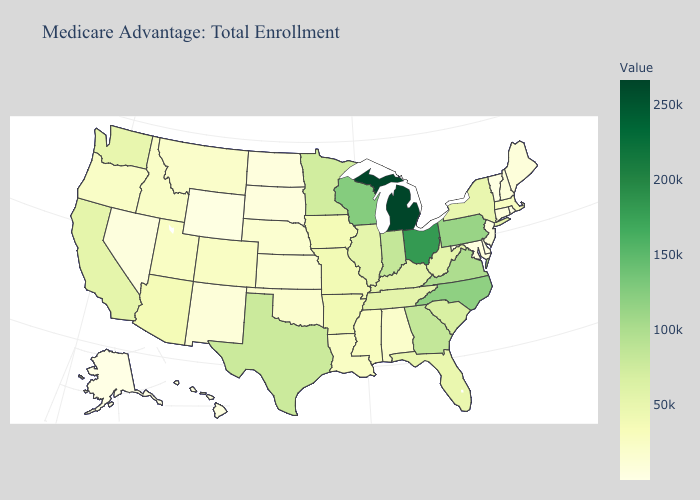Among the states that border North Dakota , does Minnesota have the lowest value?
Give a very brief answer. No. Among the states that border Illinois , does Wisconsin have the highest value?
Short answer required. Yes. Among the states that border Vermont , which have the highest value?
Quick response, please. New York. Does Arizona have a lower value than Minnesota?
Give a very brief answer. Yes. 